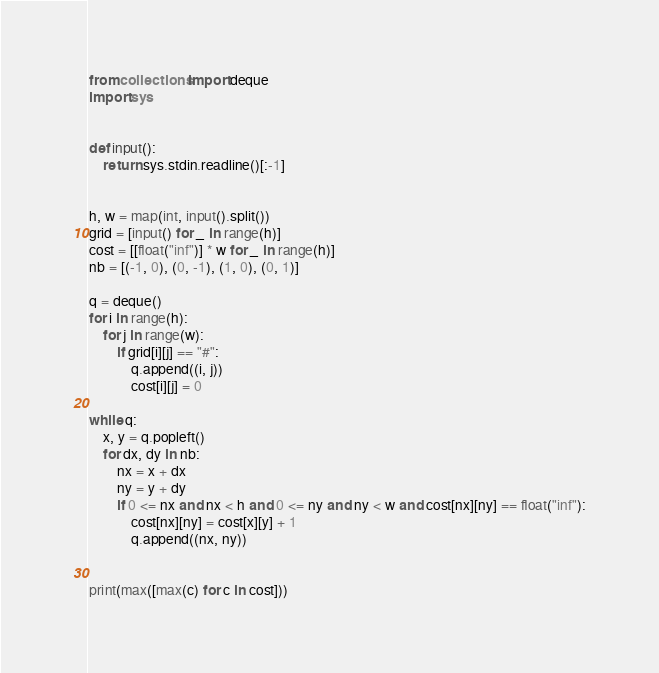<code> <loc_0><loc_0><loc_500><loc_500><_Python_>from collections import deque
import sys


def input():
    return sys.stdin.readline()[:-1]


h, w = map(int, input().split())
grid = [input() for _ in range(h)]
cost = [[float("inf")] * w for _ in range(h)]
nb = [(-1, 0), (0, -1), (1, 0), (0, 1)]

q = deque()
for i in range(h):
    for j in range(w):
        if grid[i][j] == "#":
            q.append((i, j))
            cost[i][j] = 0

while q:
    x, y = q.popleft()
    for dx, dy in nb:
        nx = x + dx
        ny = y + dy
        if 0 <= nx and nx < h and 0 <= ny and ny < w and cost[nx][ny] == float("inf"):
            cost[nx][ny] = cost[x][y] + 1
            q.append((nx, ny))


print(max([max(c) for c in cost]))
</code> 